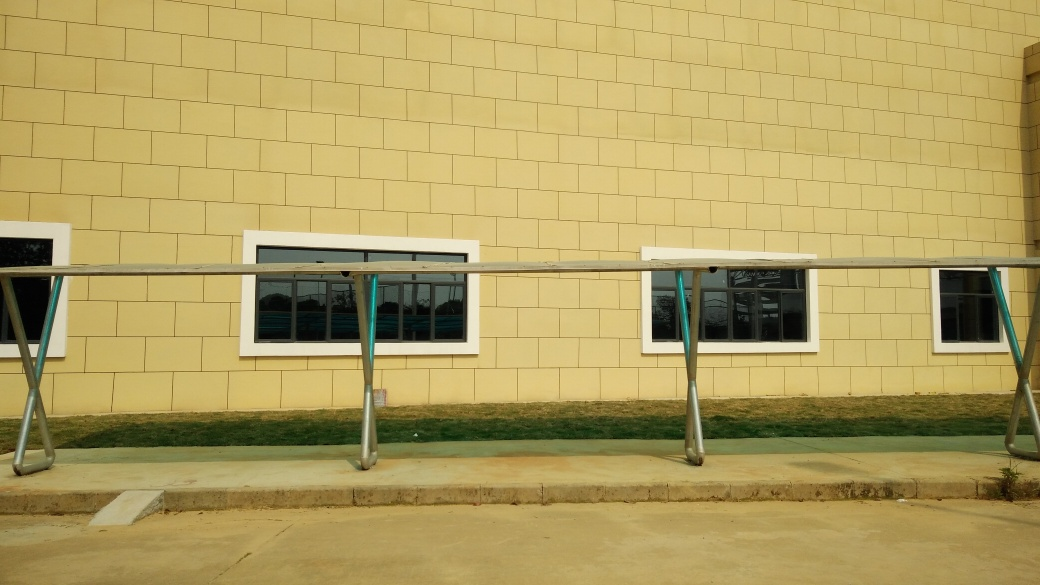What is the overall quality of this image?
A. The overall quality of this image is poor.
B. The overall quality of this image is average.
C. The overall quality of this image is very good.
Answer with the option's letter from the given choices directly.
 C. 